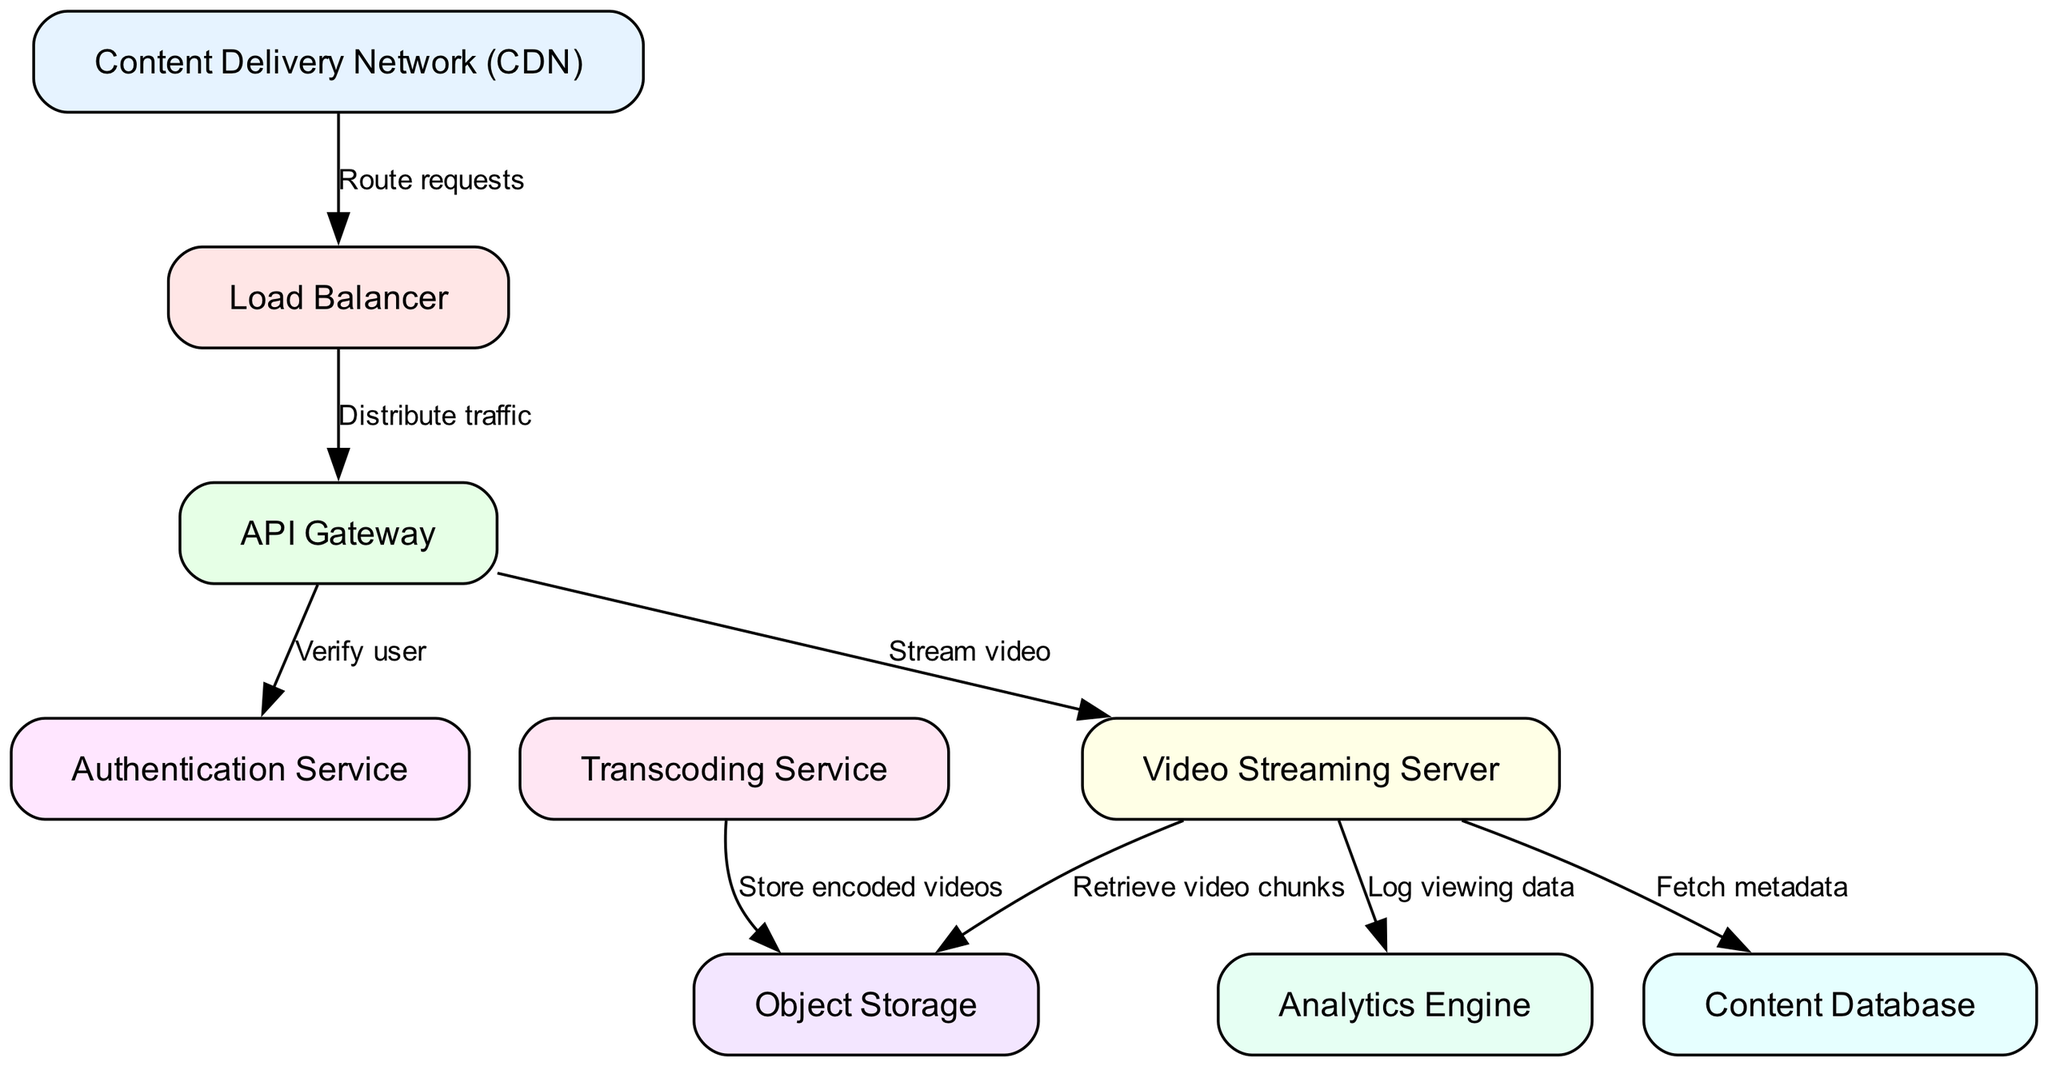What is the total number of nodes in the diagram? The diagram lists a total of 9 nodes, which consist of the Content Delivery Network, Load Balancer, API Gateway, Authentication Service, Video Streaming Server, Content Database, Transcoding Service, Object Storage, and Analytics Engine.
Answer: 9 Which node connects directly to the API Gateway? The API Gateway connects directly to the Authentication Service and the Video Streaming Server based on the edges in the diagram.
Answer: Authentication Service, Video Streaming Server What type of service is the Transcoding Service? The Transcoding Service is depicted as a service that stores encoded videos in the Object Storage according to the edge connecting these nodes.
Answer: Service What is the purpose of the Load Balancer? The Load Balancer's role is to distribute incoming traffic from the Content Delivery Network to the API Gateway, ensuring efficient handling of requests.
Answer: Distribute traffic Which node retrieves video chunks from storage? The Video Streaming Server retrieves video chunks from the Object Storage as indicated by the connecting edge labelled "Retrieve video chunks."
Answer: Video Streaming Server How many edges are there that connect different nodes in the diagram? There are a total of 8 edges that connect the nodes, representing interactions and data flow between the various components of the architecture.
Answer: 8 What data does the Video Streaming Server log? The Video Streaming Server logs viewing data, as shown by its connection to the Analytics Engine, which is responsible for processing this information.
Answer: Viewing data Which component is responsible for verifying users? The Authentication Service is responsible for verifying users, as it is connected directly to the API Gateway for authentication purposes.
Answer: Authentication Service What does the CDN do? The Content Delivery Network routes requests to the Load Balancer to manage and allocate incoming user traffic effectively.
Answer: Route requests 